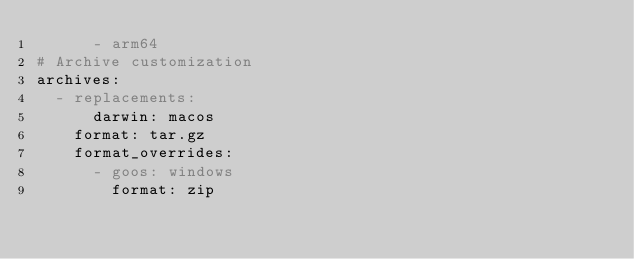Convert code to text. <code><loc_0><loc_0><loc_500><loc_500><_YAML_>      - arm64
# Archive customization
archives:
  - replacements:
      darwin: macos
    format: tar.gz
    format_overrides:
      - goos: windows
        format: zip
</code> 